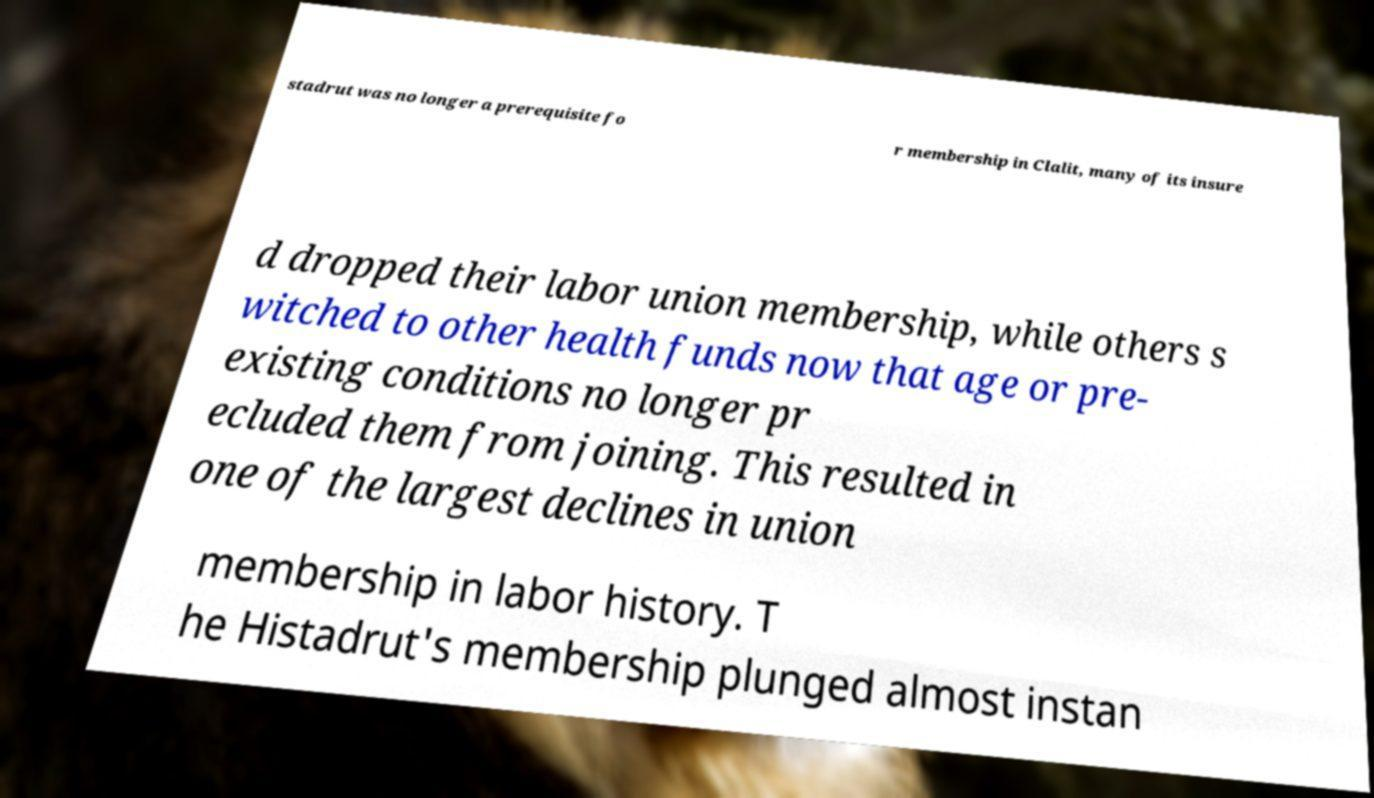Please read and relay the text visible in this image. What does it say? stadrut was no longer a prerequisite fo r membership in Clalit, many of its insure d dropped their labor union membership, while others s witched to other health funds now that age or pre- existing conditions no longer pr ecluded them from joining. This resulted in one of the largest declines in union membership in labor history. T he Histadrut's membership plunged almost instan 